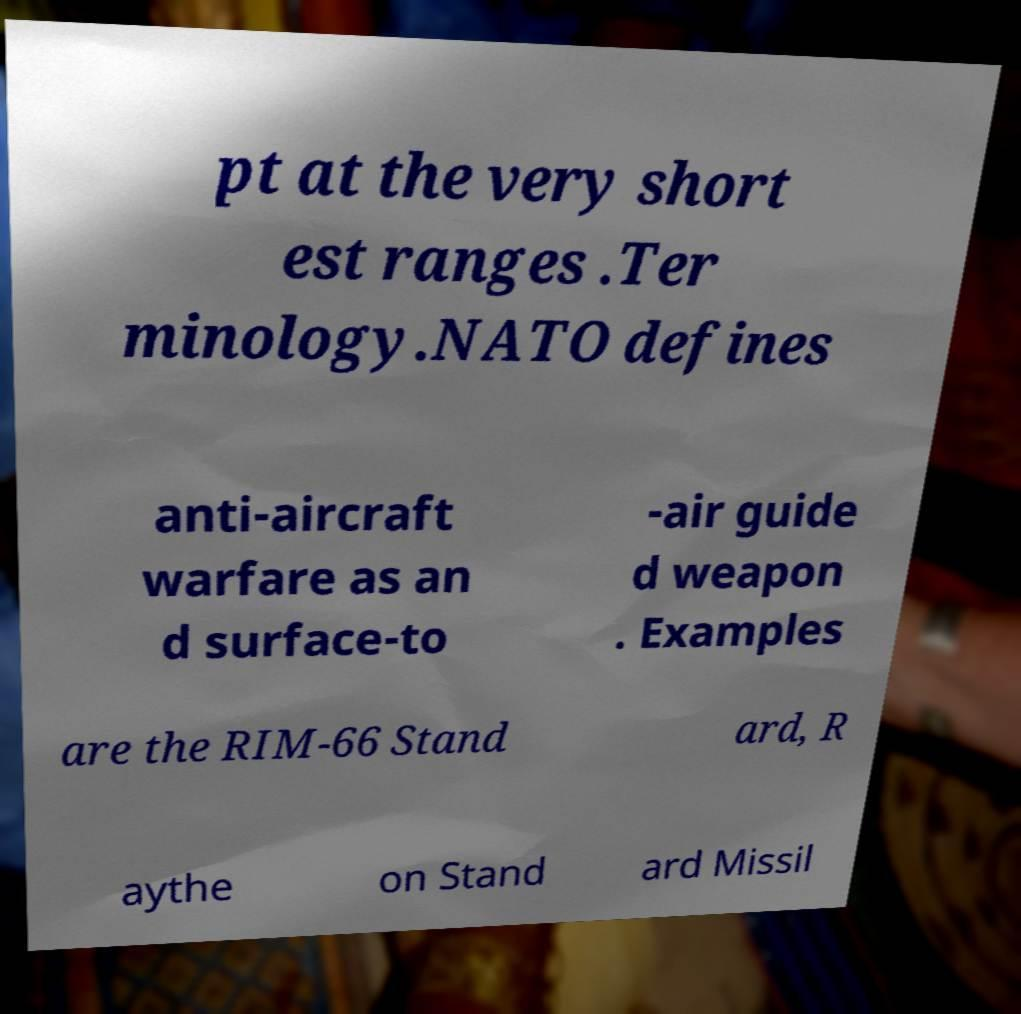What messages or text are displayed in this image? I need them in a readable, typed format. pt at the very short est ranges .Ter minology.NATO defines anti-aircraft warfare as an d surface-to -air guide d weapon . Examples are the RIM-66 Stand ard, R aythe on Stand ard Missil 